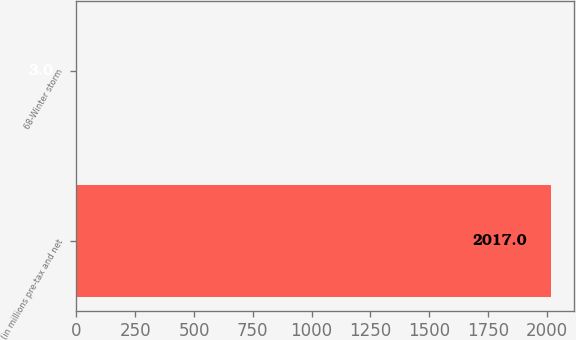<chart> <loc_0><loc_0><loc_500><loc_500><bar_chart><fcel>(in millions pre-tax and net<fcel>68-Winter storm<nl><fcel>2017<fcel>3<nl></chart> 